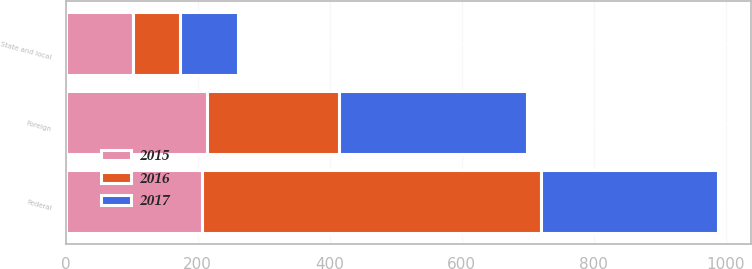Convert chart. <chart><loc_0><loc_0><loc_500><loc_500><stacked_bar_chart><ecel><fcel>Federal<fcel>State and local<fcel>Foreign<nl><fcel>2017<fcel>269<fcel>88<fcel>285<nl><fcel>2016<fcel>513<fcel>72<fcel>200<nl><fcel>2015<fcel>207<fcel>102<fcel>214<nl></chart> 